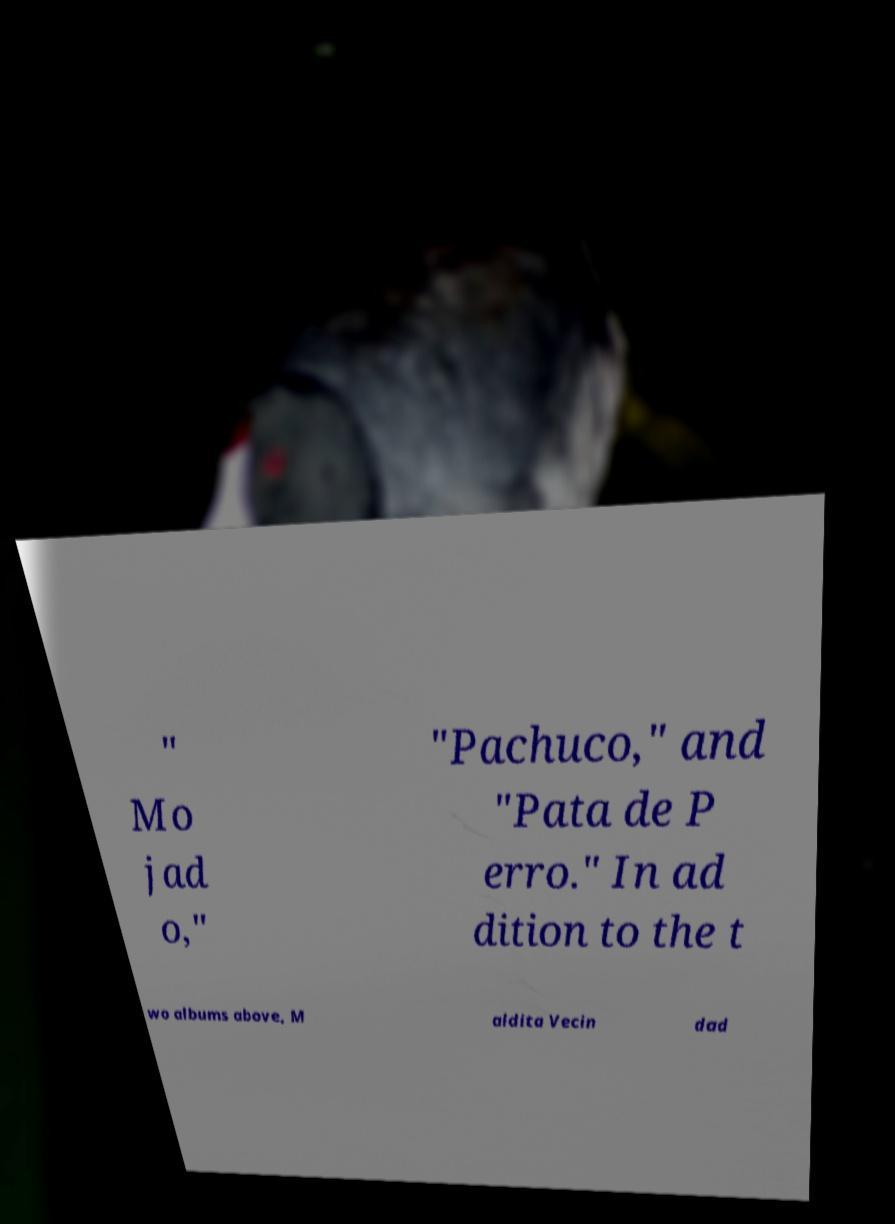What messages or text are displayed in this image? I need them in a readable, typed format. " Mo jad o," "Pachuco," and "Pata de P erro." In ad dition to the t wo albums above, M aldita Vecin dad 